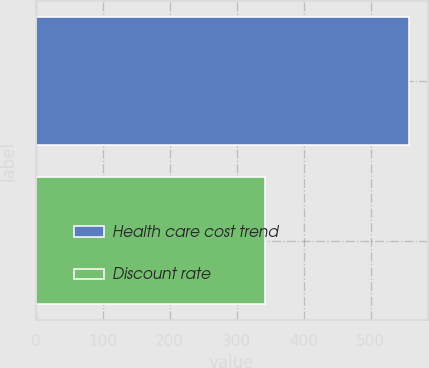Convert chart to OTSL. <chart><loc_0><loc_0><loc_500><loc_500><bar_chart><fcel>Health care cost trend<fcel>Discount rate<nl><fcel>557<fcel>342<nl></chart> 